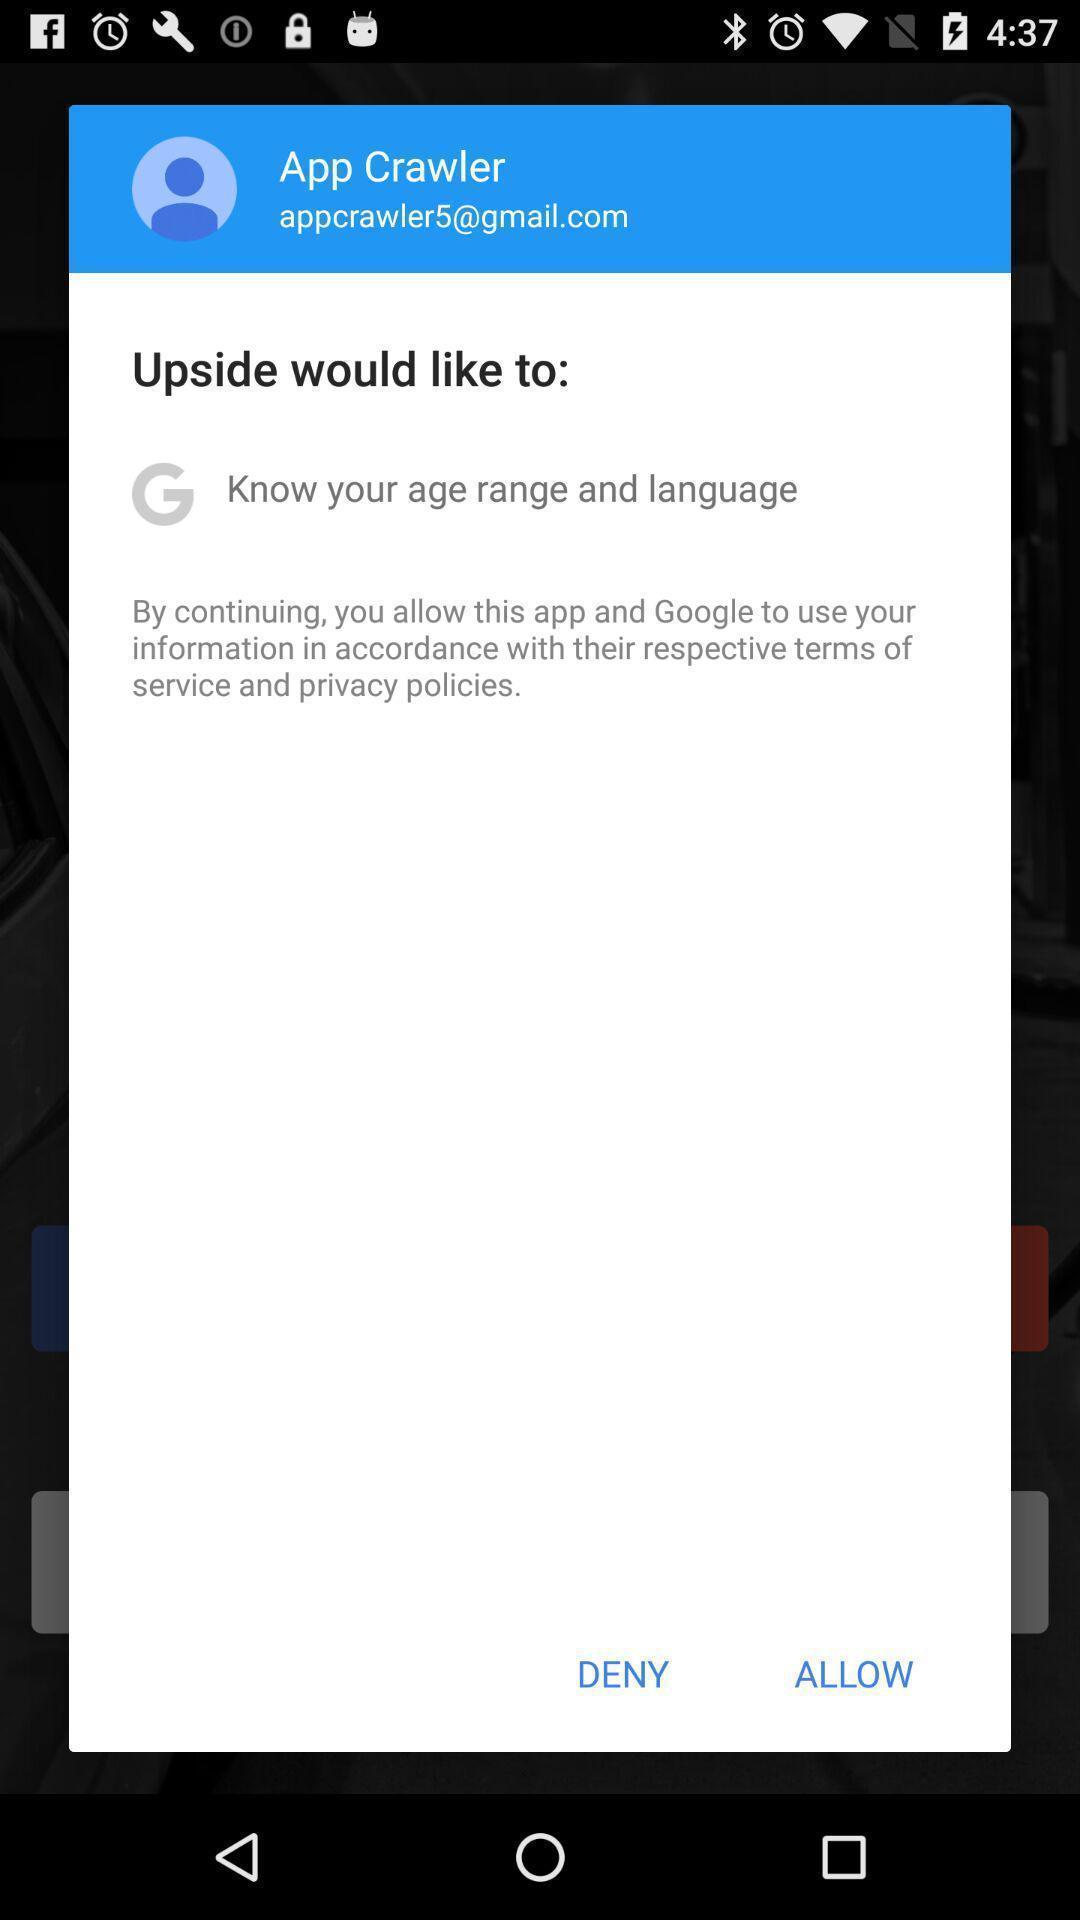Describe the visual elements of this screenshot. Popup page for allowing terms and conditions. 